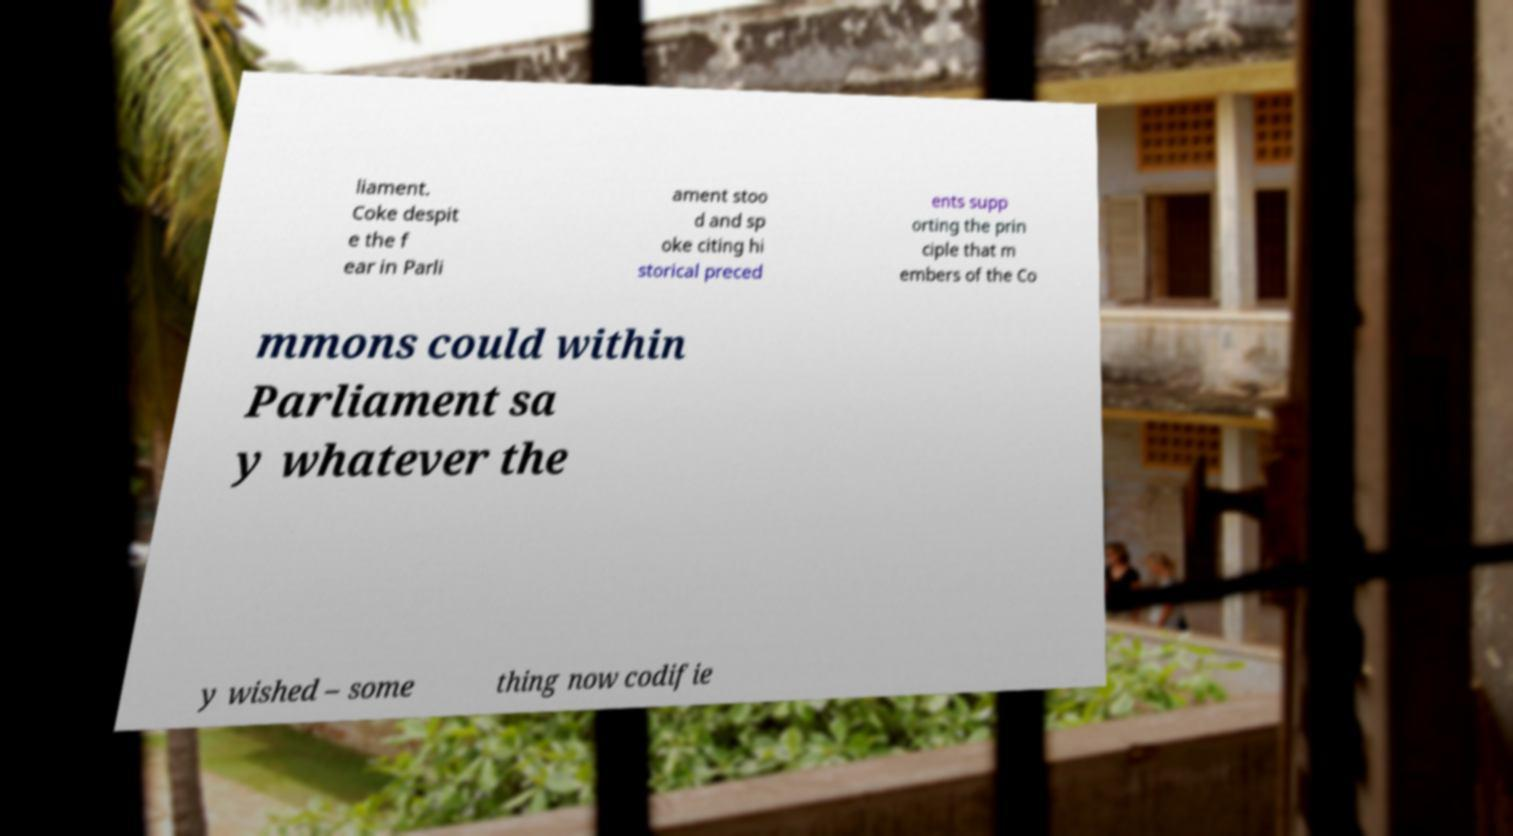Could you extract and type out the text from this image? liament. Coke despit e the f ear in Parli ament stoo d and sp oke citing hi storical preced ents supp orting the prin ciple that m embers of the Co mmons could within Parliament sa y whatever the y wished – some thing now codifie 